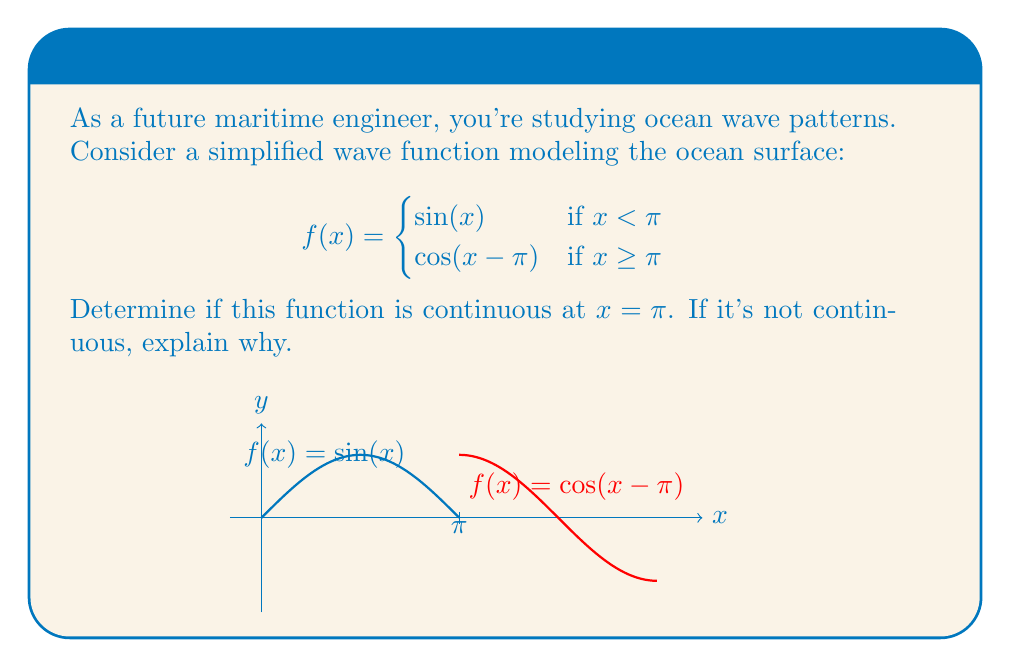Help me with this question. To determine if the function is continuous at $x = \pi$, we need to check three conditions:

1. $f(x)$ is defined at $x = \pi$
2. $\lim_{x \to \pi^-} f(x)$ exists
3. $\lim_{x \to \pi^+} f(x)$ exists
4. $\lim_{x \to \pi^-} f(x) = \lim_{x \to \pi^+} f(x) = f(\pi)$

Let's check each condition:

1. $f(\pi)$ is defined:
   $f(\pi) = \cos(\pi-\pi) = \cos(0) = 1$

2. $\lim_{x \to \pi^-} f(x)$:
   $\lim_{x \to \pi^-} \sin(x) = \sin(\pi) = 0$

3. $\lim_{x \to \pi^+} f(x)$:
   $\lim_{x \to \pi^+} \cos(x-\pi) = \cos(0) = 1$

4. Comparing the limits and function value:
   $\lim_{x \to \pi^-} f(x) = 0$
   $\lim_{x \to \pi^+} f(x) = 1$
   $f(\pi) = 1$

We can see that $\lim_{x \to \pi^-} f(x) \neq \lim_{x \to \pi^+} f(x)$, which means the left-hand limit does not equal the right-hand limit. This violates the condition for continuity.

Therefore, the function is not continuous at $x = \pi$. There is a jump discontinuity at this point, as the function value abruptly changes from 0 to 1.
Answer: Not continuous at $x = \pi$ due to jump discontinuity 